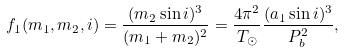Convert formula to latex. <formula><loc_0><loc_0><loc_500><loc_500>f _ { 1 } ( m _ { 1 } , m _ { 2 } , i ) = \frac { ( m _ { 2 } \sin i ) ^ { 3 } } { ( m _ { 1 } + m _ { 2 } ) ^ { 2 } } = \frac { 4 \pi ^ { 2 } } { T _ { \odot } } \frac { ( a _ { 1 } \sin i ) ^ { 3 } } { P _ { b } ^ { 2 } } ,</formula> 